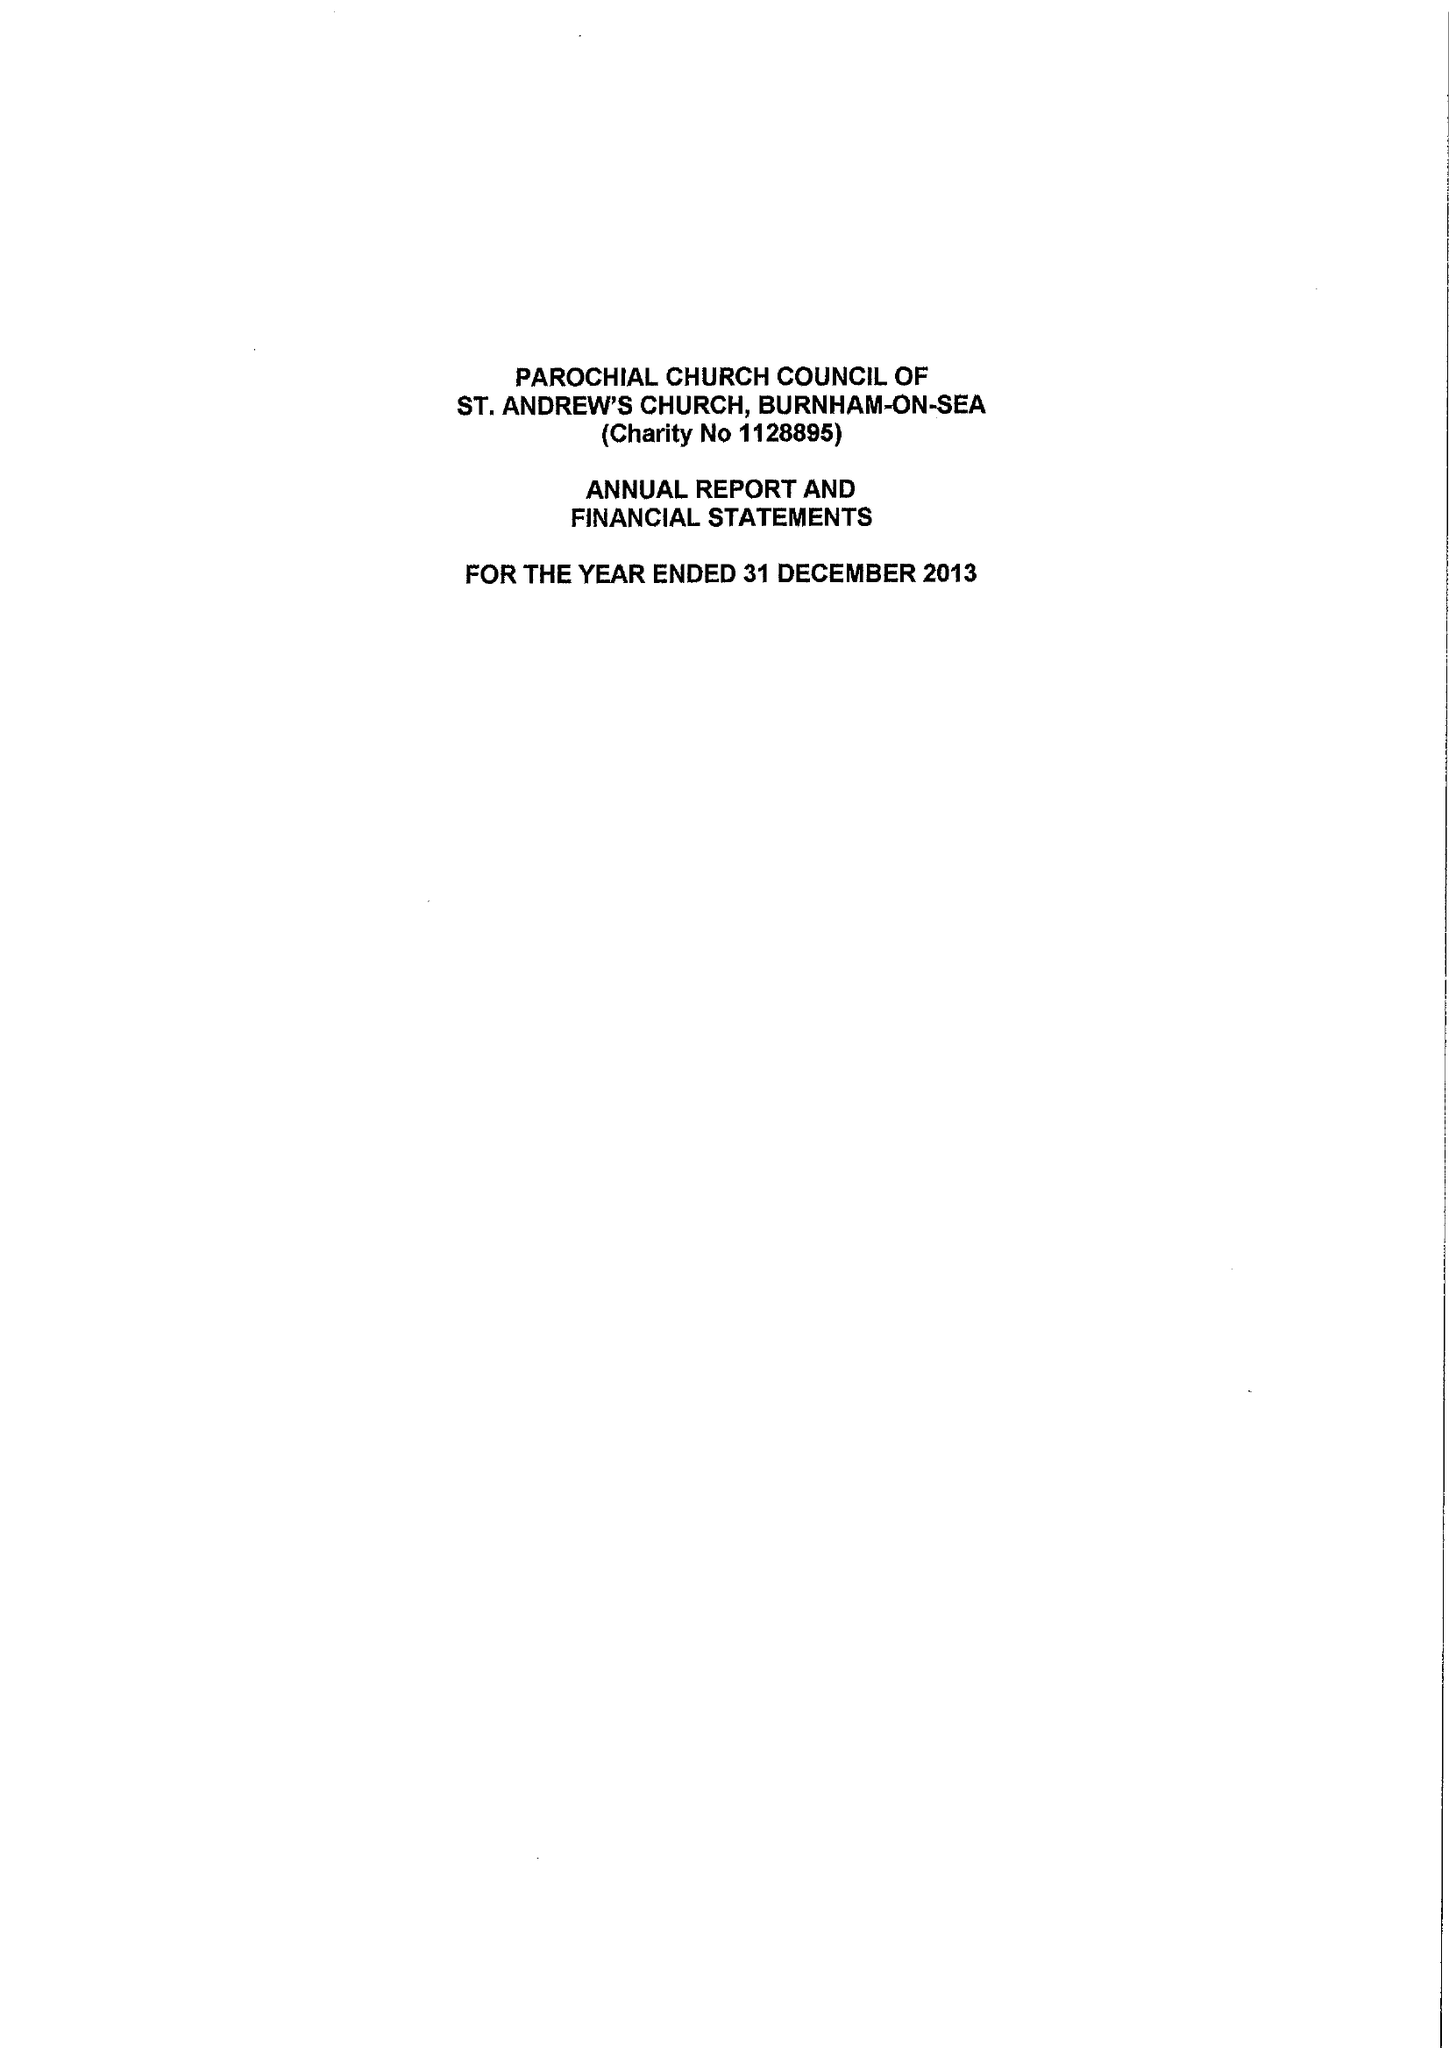What is the value for the address__post_town?
Answer the question using a single word or phrase. BURNHAM-ON-SEA 